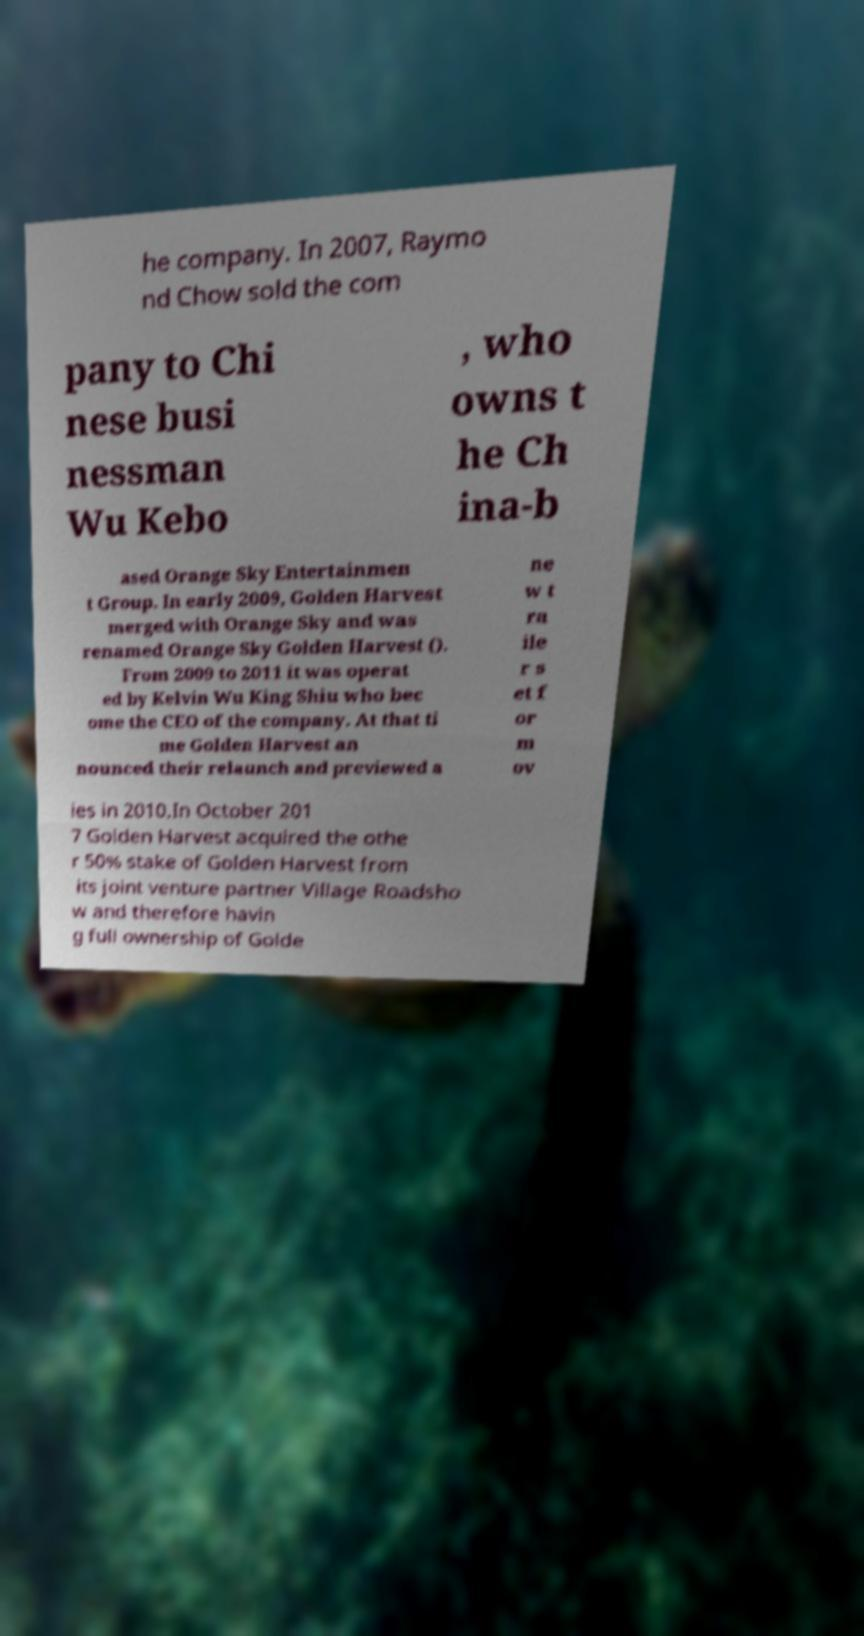There's text embedded in this image that I need extracted. Can you transcribe it verbatim? he company. In 2007, Raymo nd Chow sold the com pany to Chi nese busi nessman Wu Kebo , who owns t he Ch ina-b ased Orange Sky Entertainmen t Group. In early 2009, Golden Harvest merged with Orange Sky and was renamed Orange Sky Golden Harvest (). From 2009 to 2011 it was operat ed by Kelvin Wu King Shiu who bec ome the CEO of the company. At that ti me Golden Harvest an nounced their relaunch and previewed a ne w t ra ile r s et f or m ov ies in 2010.In October 201 7 Golden Harvest acquired the othe r 50% stake of Golden Harvest from its joint venture partner Village Roadsho w and therefore havin g full ownership of Golde 